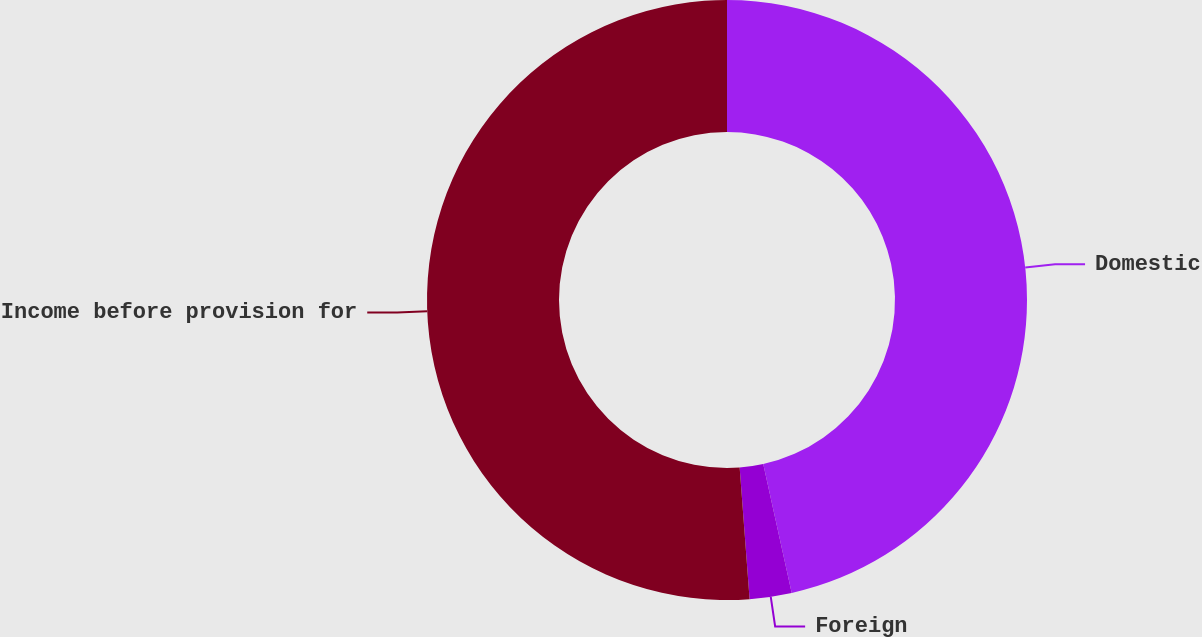<chart> <loc_0><loc_0><loc_500><loc_500><pie_chart><fcel>Domestic<fcel>Foreign<fcel>Income before provision for<nl><fcel>46.54%<fcel>2.26%<fcel>51.2%<nl></chart> 